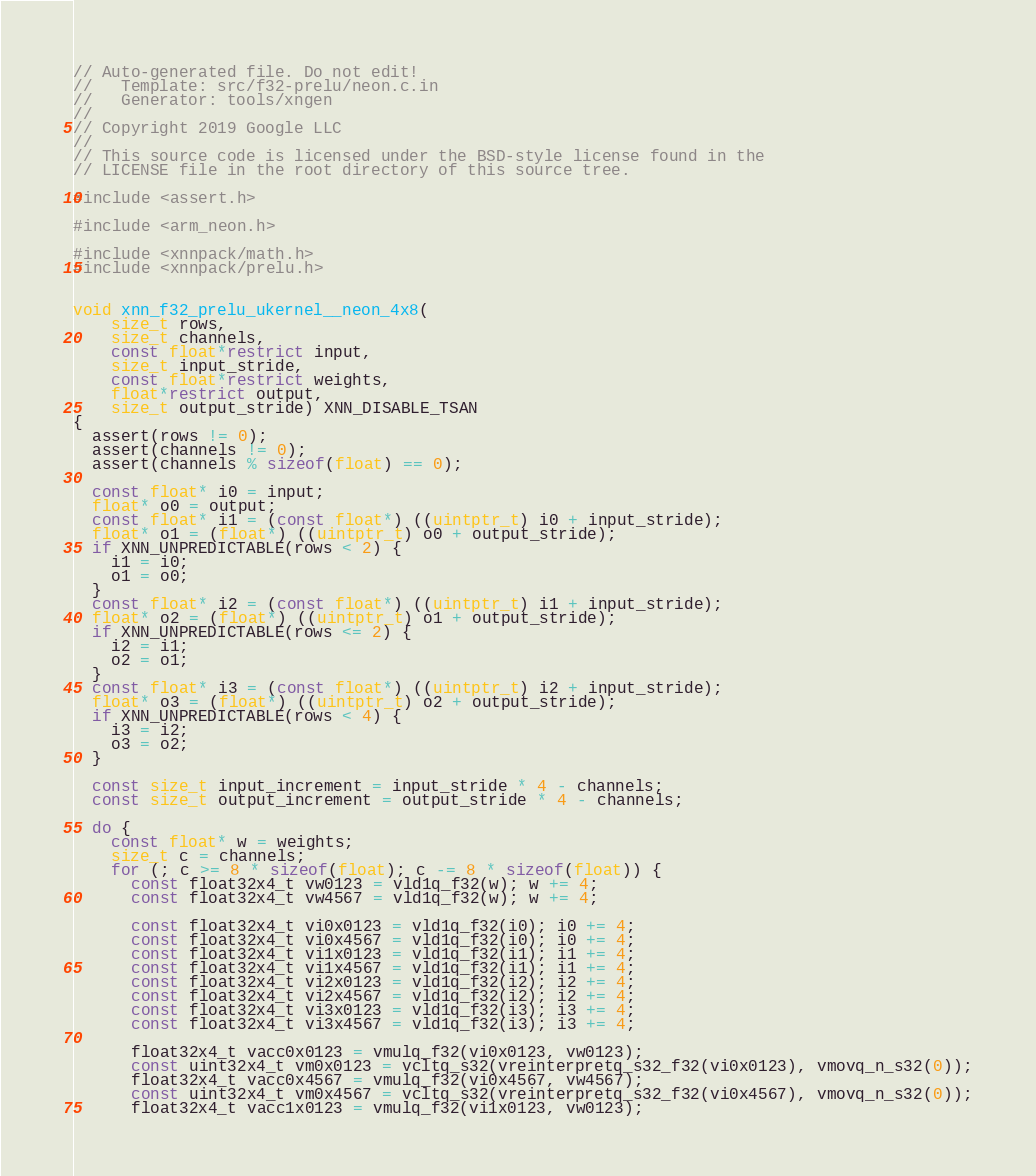<code> <loc_0><loc_0><loc_500><loc_500><_C_>// Auto-generated file. Do not edit!
//   Template: src/f32-prelu/neon.c.in
//   Generator: tools/xngen
//
// Copyright 2019 Google LLC
//
// This source code is licensed under the BSD-style license found in the
// LICENSE file in the root directory of this source tree.

#include <assert.h>

#include <arm_neon.h>

#include <xnnpack/math.h>
#include <xnnpack/prelu.h>


void xnn_f32_prelu_ukernel__neon_4x8(
    size_t rows,
    size_t channels,
    const float*restrict input,
    size_t input_stride,
    const float*restrict weights,
    float*restrict output,
    size_t output_stride) XNN_DISABLE_TSAN
{
  assert(rows != 0);
  assert(channels != 0);
  assert(channels % sizeof(float) == 0);

  const float* i0 = input;
  float* o0 = output;
  const float* i1 = (const float*) ((uintptr_t) i0 + input_stride);
  float* o1 = (float*) ((uintptr_t) o0 + output_stride);
  if XNN_UNPREDICTABLE(rows < 2) {
    i1 = i0;
    o1 = o0;
  }
  const float* i2 = (const float*) ((uintptr_t) i1 + input_stride);
  float* o2 = (float*) ((uintptr_t) o1 + output_stride);
  if XNN_UNPREDICTABLE(rows <= 2) {
    i2 = i1;
    o2 = o1;
  }
  const float* i3 = (const float*) ((uintptr_t) i2 + input_stride);
  float* o3 = (float*) ((uintptr_t) o2 + output_stride);
  if XNN_UNPREDICTABLE(rows < 4) {
    i3 = i2;
    o3 = o2;
  }

  const size_t input_increment = input_stride * 4 - channels;
  const size_t output_increment = output_stride * 4 - channels;

  do {
    const float* w = weights;
    size_t c = channels;
    for (; c >= 8 * sizeof(float); c -= 8 * sizeof(float)) {
      const float32x4_t vw0123 = vld1q_f32(w); w += 4;
      const float32x4_t vw4567 = vld1q_f32(w); w += 4;

      const float32x4_t vi0x0123 = vld1q_f32(i0); i0 += 4;
      const float32x4_t vi0x4567 = vld1q_f32(i0); i0 += 4;
      const float32x4_t vi1x0123 = vld1q_f32(i1); i1 += 4;
      const float32x4_t vi1x4567 = vld1q_f32(i1); i1 += 4;
      const float32x4_t vi2x0123 = vld1q_f32(i2); i2 += 4;
      const float32x4_t vi2x4567 = vld1q_f32(i2); i2 += 4;
      const float32x4_t vi3x0123 = vld1q_f32(i3); i3 += 4;
      const float32x4_t vi3x4567 = vld1q_f32(i3); i3 += 4;

      float32x4_t vacc0x0123 = vmulq_f32(vi0x0123, vw0123);
      const uint32x4_t vm0x0123 = vcltq_s32(vreinterpretq_s32_f32(vi0x0123), vmovq_n_s32(0));
      float32x4_t vacc0x4567 = vmulq_f32(vi0x4567, vw4567);
      const uint32x4_t vm0x4567 = vcltq_s32(vreinterpretq_s32_f32(vi0x4567), vmovq_n_s32(0));
      float32x4_t vacc1x0123 = vmulq_f32(vi1x0123, vw0123);</code> 